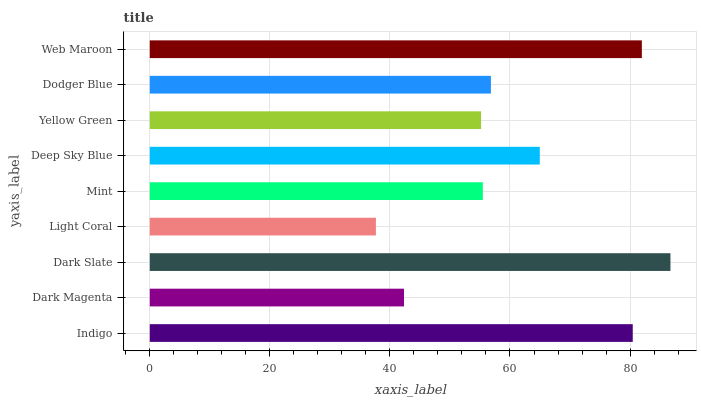Is Light Coral the minimum?
Answer yes or no. Yes. Is Dark Slate the maximum?
Answer yes or no. Yes. Is Dark Magenta the minimum?
Answer yes or no. No. Is Dark Magenta the maximum?
Answer yes or no. No. Is Indigo greater than Dark Magenta?
Answer yes or no. Yes. Is Dark Magenta less than Indigo?
Answer yes or no. Yes. Is Dark Magenta greater than Indigo?
Answer yes or no. No. Is Indigo less than Dark Magenta?
Answer yes or no. No. Is Dodger Blue the high median?
Answer yes or no. Yes. Is Dodger Blue the low median?
Answer yes or no. Yes. Is Web Maroon the high median?
Answer yes or no. No. Is Deep Sky Blue the low median?
Answer yes or no. No. 